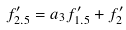Convert formula to latex. <formula><loc_0><loc_0><loc_500><loc_500>f ^ { \prime } _ { 2 . 5 } = a _ { 3 } f ^ { \prime } _ { 1 . 5 } + f ^ { \prime } _ { 2 }</formula> 